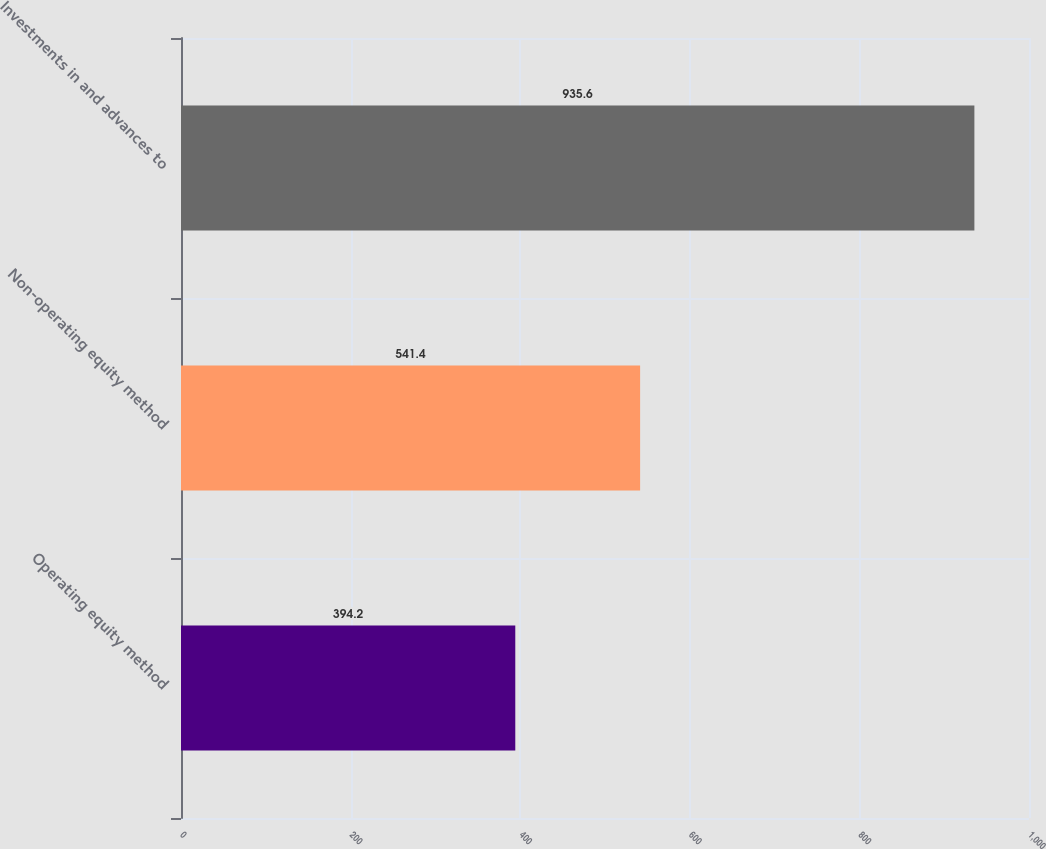Convert chart. <chart><loc_0><loc_0><loc_500><loc_500><bar_chart><fcel>Operating equity method<fcel>Non-operating equity method<fcel>Investments in and advances to<nl><fcel>394.2<fcel>541.4<fcel>935.6<nl></chart> 